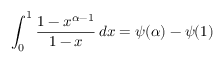Convert formula to latex. <formula><loc_0><loc_0><loc_500><loc_500>\int _ { 0 } ^ { 1 } { \frac { 1 - x ^ { \alpha - 1 } } { 1 - x } } \, d x = \psi ( \alpha ) - \psi ( 1 )</formula> 